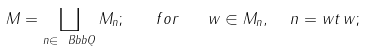Convert formula to latex. <formula><loc_0><loc_0><loc_500><loc_500>M = \coprod _ { n \in { \ B b b Q } } M _ { n } ; \quad f o r \quad w \in M _ { n } , \ \ n = w t \, w ;</formula> 